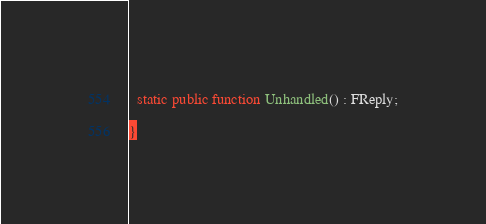Convert code to text. <code><loc_0><loc_0><loc_500><loc_500><_Haxe_>  static public function Unhandled() : FReply;

}</code> 